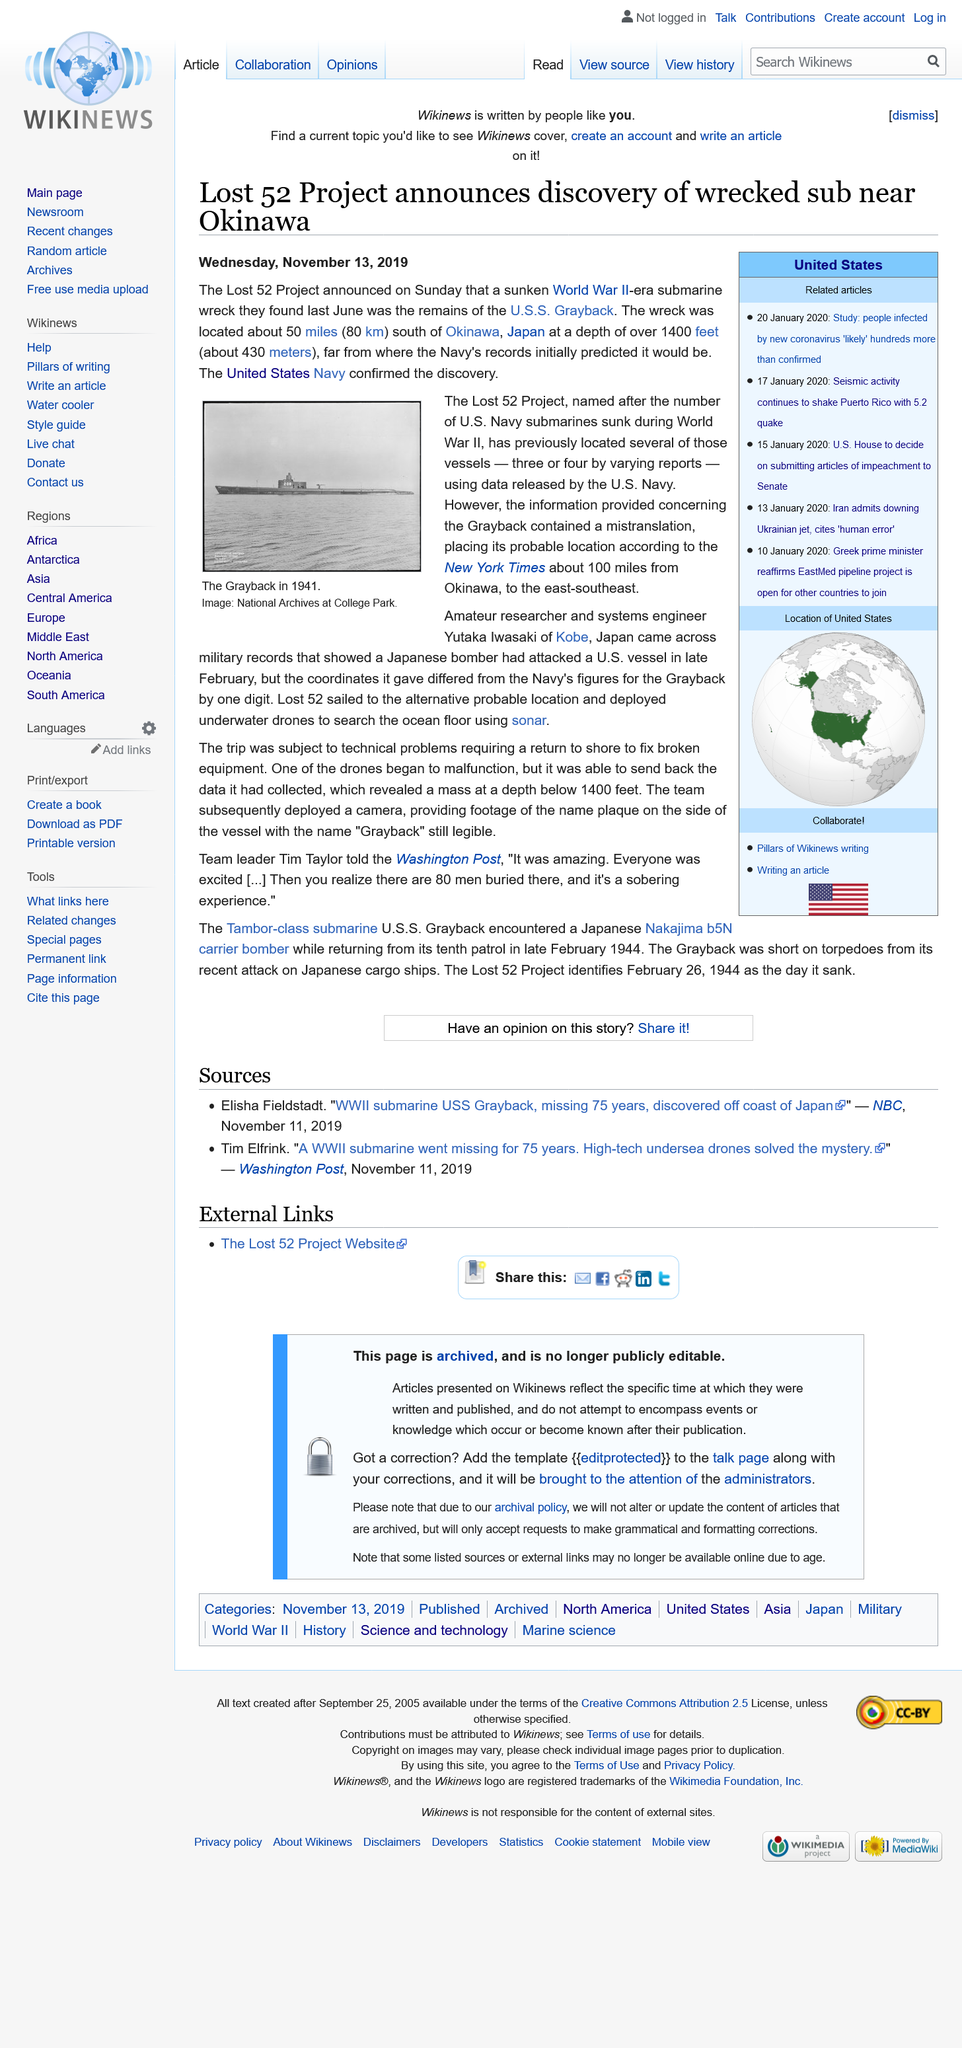Outline some significant characteristics in this image. The wreck of the submarine was discovered in June 2018. The photograph shows the U.S.S. Grayback, a submarine, in 1941. 